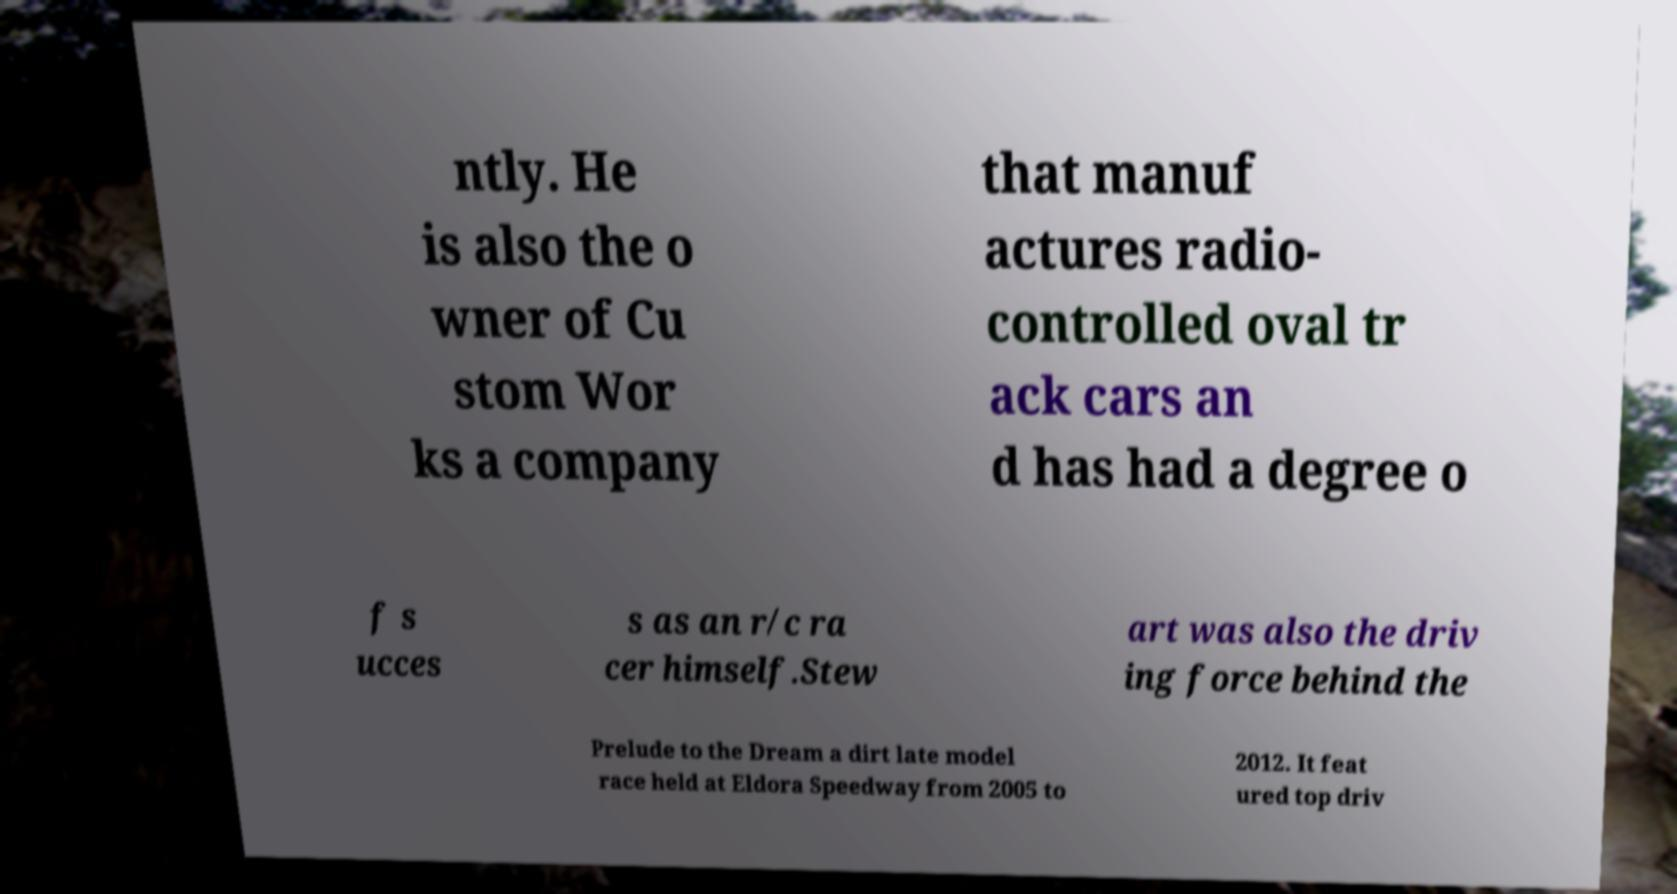Can you accurately transcribe the text from the provided image for me? ntly. He is also the o wner of Cu stom Wor ks a company that manuf actures radio- controlled oval tr ack cars an d has had a degree o f s ucces s as an r/c ra cer himself.Stew art was also the driv ing force behind the Prelude to the Dream a dirt late model race held at Eldora Speedway from 2005 to 2012. It feat ured top driv 